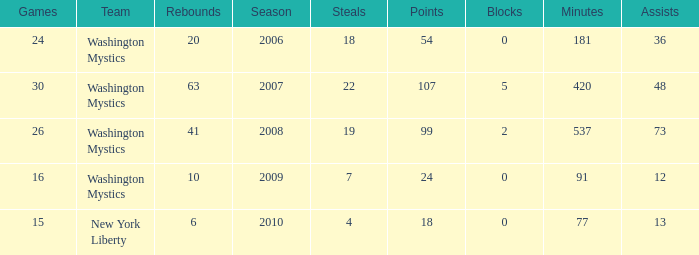What is the earliest year that Assists were less than 13 and minutes were under 91? None. 